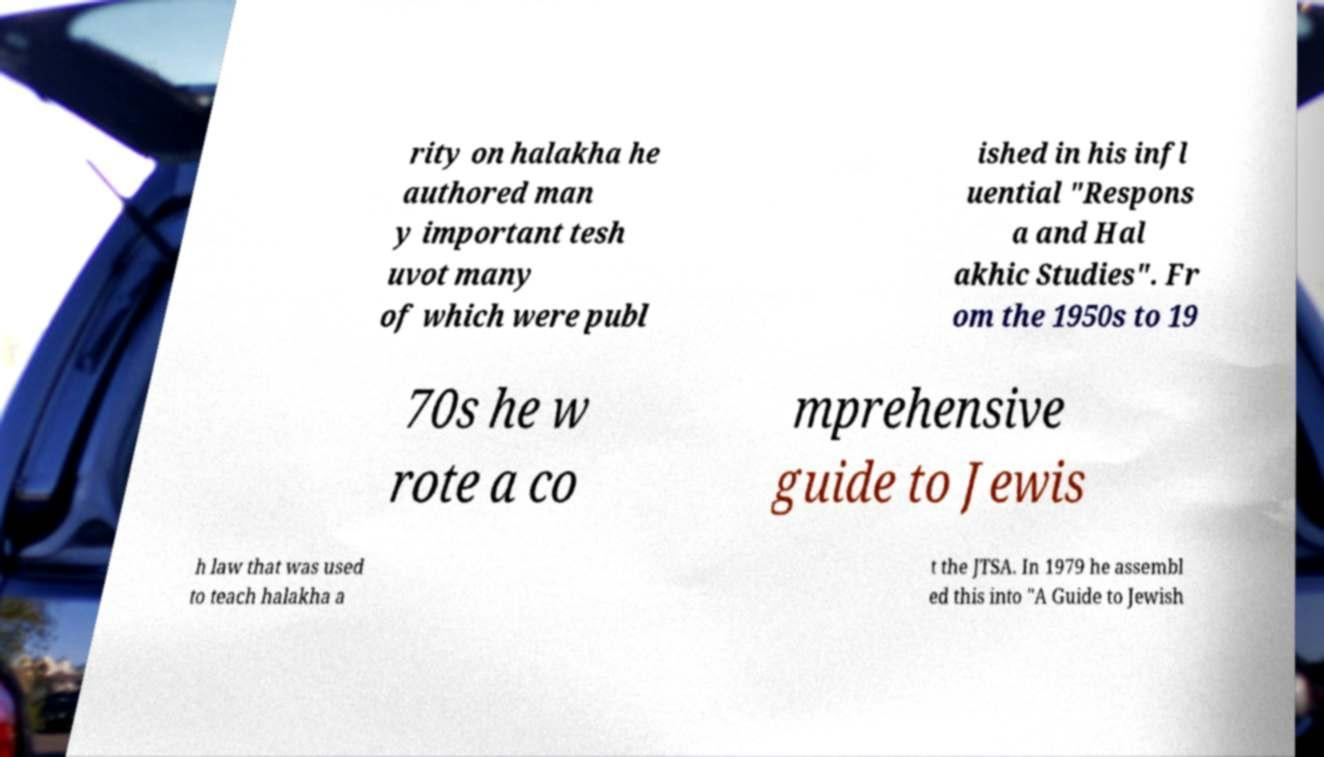Please identify and transcribe the text found in this image. rity on halakha he authored man y important tesh uvot many of which were publ ished in his infl uential "Respons a and Hal akhic Studies". Fr om the 1950s to 19 70s he w rote a co mprehensive guide to Jewis h law that was used to teach halakha a t the JTSA. In 1979 he assembl ed this into "A Guide to Jewish 